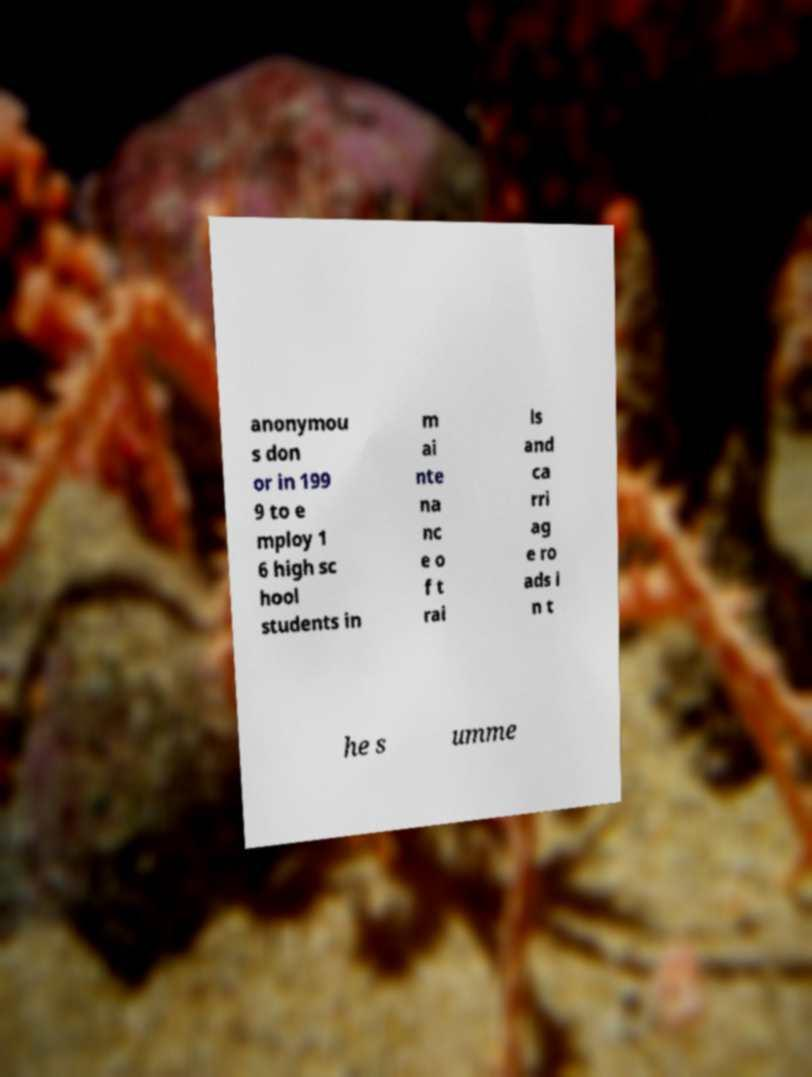What messages or text are displayed in this image? I need them in a readable, typed format. anonymou s don or in 199 9 to e mploy 1 6 high sc hool students in m ai nte na nc e o f t rai ls and ca rri ag e ro ads i n t he s umme 